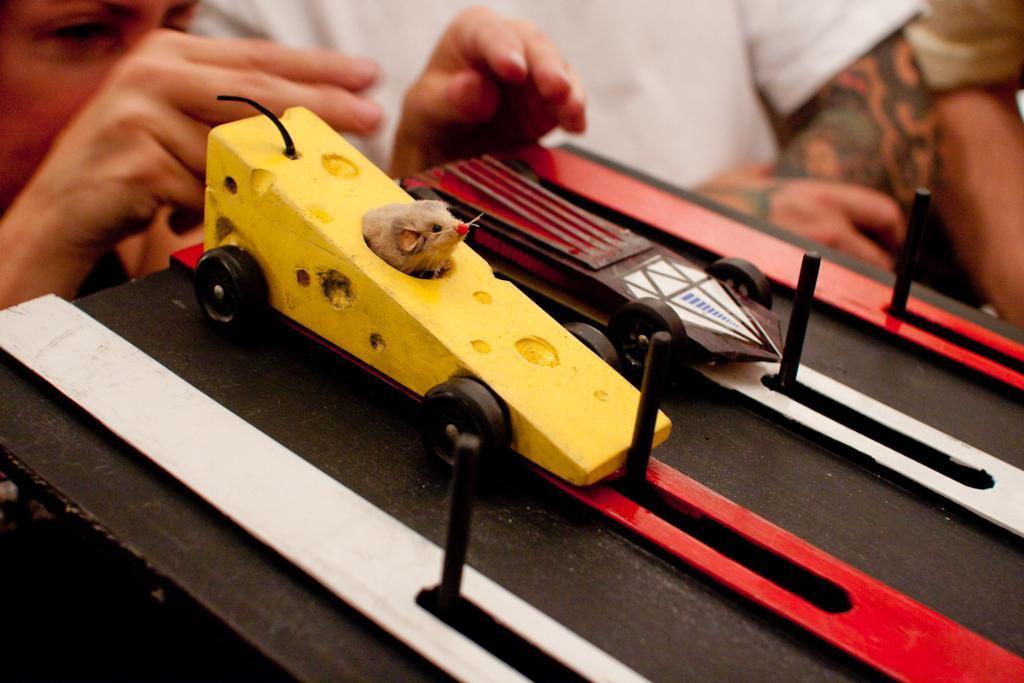Can you describe this image briefly? In this image I can see there is a person on the left side and there is a board with two cars placed on it. There are two other people standing on the right side. 